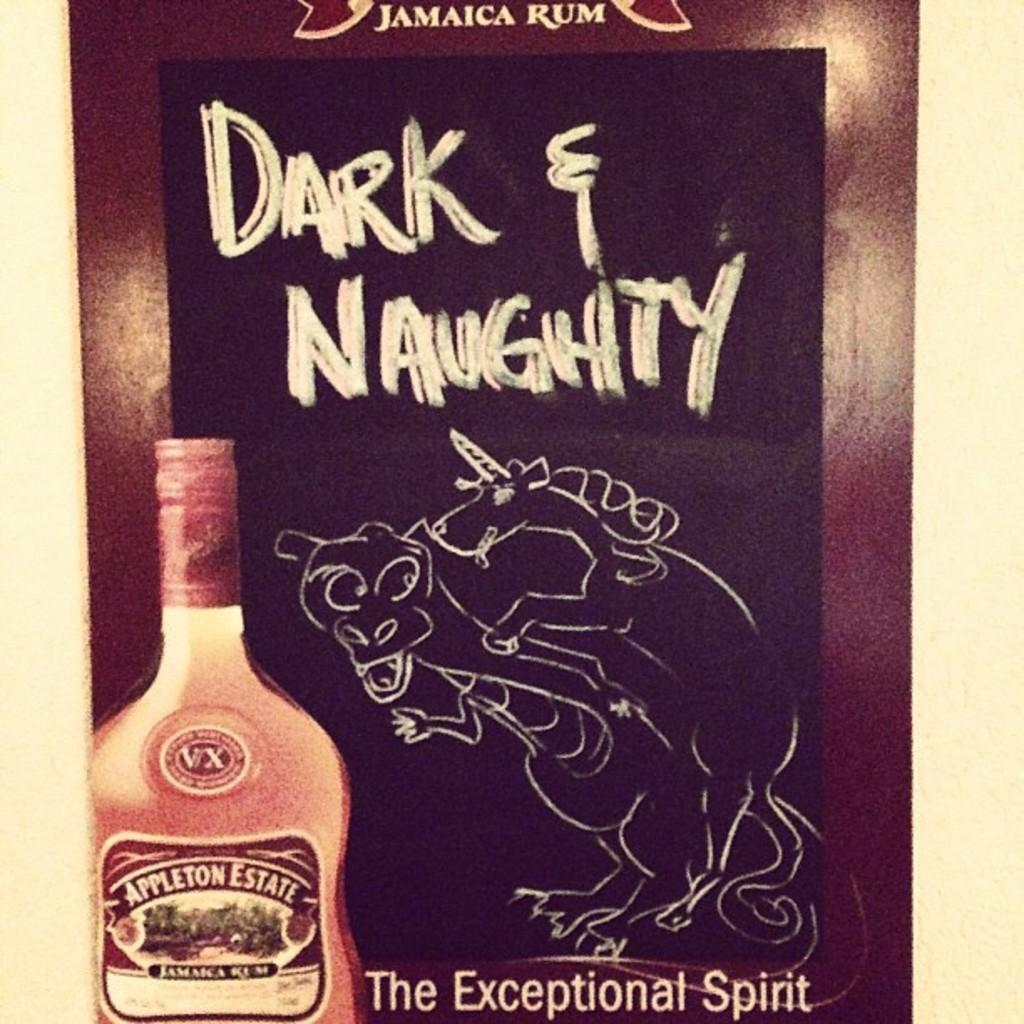<image>
Describe the image concisely. An ad for Jamaican Rum named Appleton Estate. 